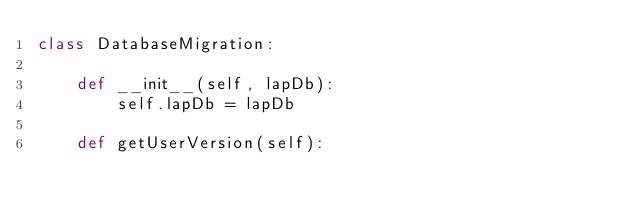<code> <loc_0><loc_0><loc_500><loc_500><_Python_>class DatabaseMigration:
    
    def __init__(self, lapDb):
        self.lapDb = lapDb
    
    def getUserVersion(self):</code> 